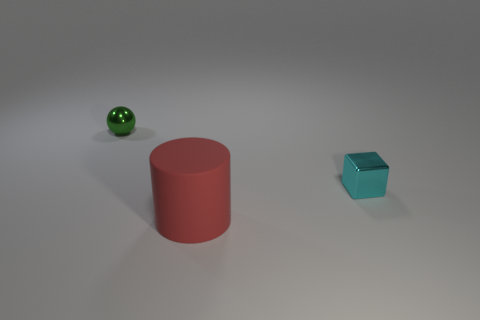Are there any other things that are made of the same material as the large cylinder?
Keep it short and to the point. No. What number of things are tiny blocks or large red matte cylinders?
Offer a very short reply. 2. How many other things are there of the same shape as the large red rubber thing?
Your answer should be very brief. 0. Are the thing in front of the tiny cyan metallic thing and the small thing that is behind the small cyan metallic cube made of the same material?
Give a very brief answer. No. The object that is behind the big cylinder and left of the small cyan shiny cube has what shape?
Provide a succinct answer. Sphere. What is the object that is both left of the tiny cyan object and behind the red thing made of?
Ensure brevity in your answer.  Metal. What is the shape of the cyan thing that is the same material as the green object?
Your answer should be compact. Cube. Is there any other thing that has the same color as the rubber cylinder?
Your answer should be compact. No. Is the number of green shiny balls to the right of the small cyan thing greater than the number of small red rubber cylinders?
Keep it short and to the point. No. What is the cylinder made of?
Make the answer very short. Rubber. 